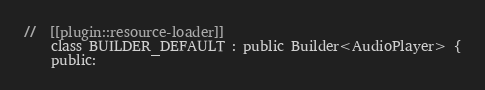<code> <loc_0><loc_0><loc_500><loc_500><_C_>
//  [[plugin::resource-loader]]
    class BUILDER_DEFAULT : public Builder<AudioPlayer> {
    public:</code> 